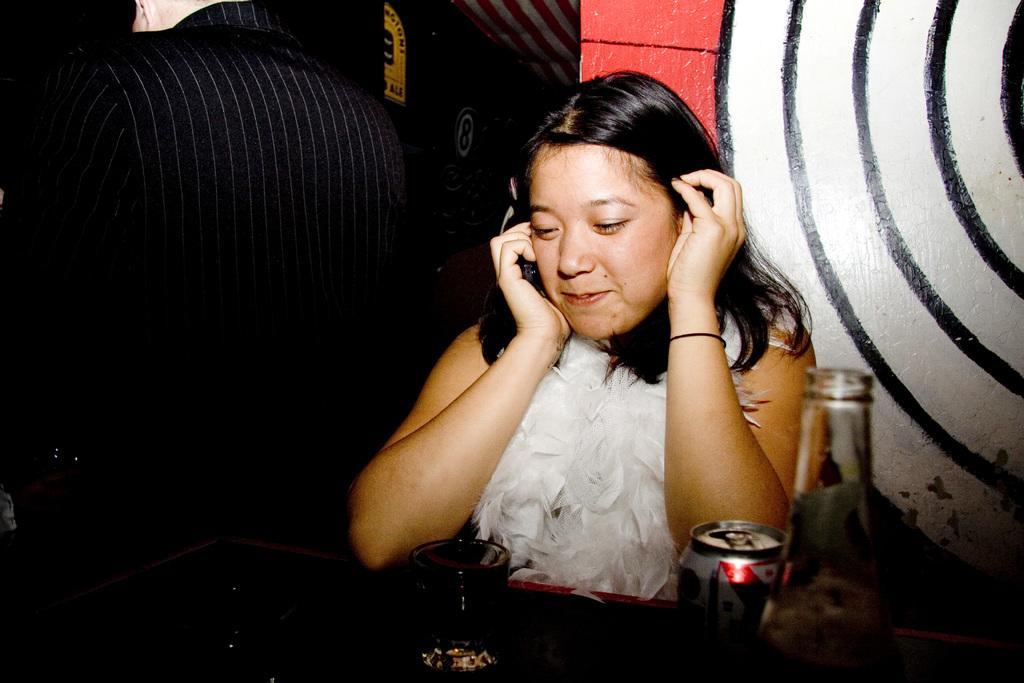Could you give a brief overview of what you see in this image? In this image we can see a woman and she is smiling. There is a table. On the table we can see a glass, tin, and a bottle. In the background we can see wall, boards, and a person who is truncated. 